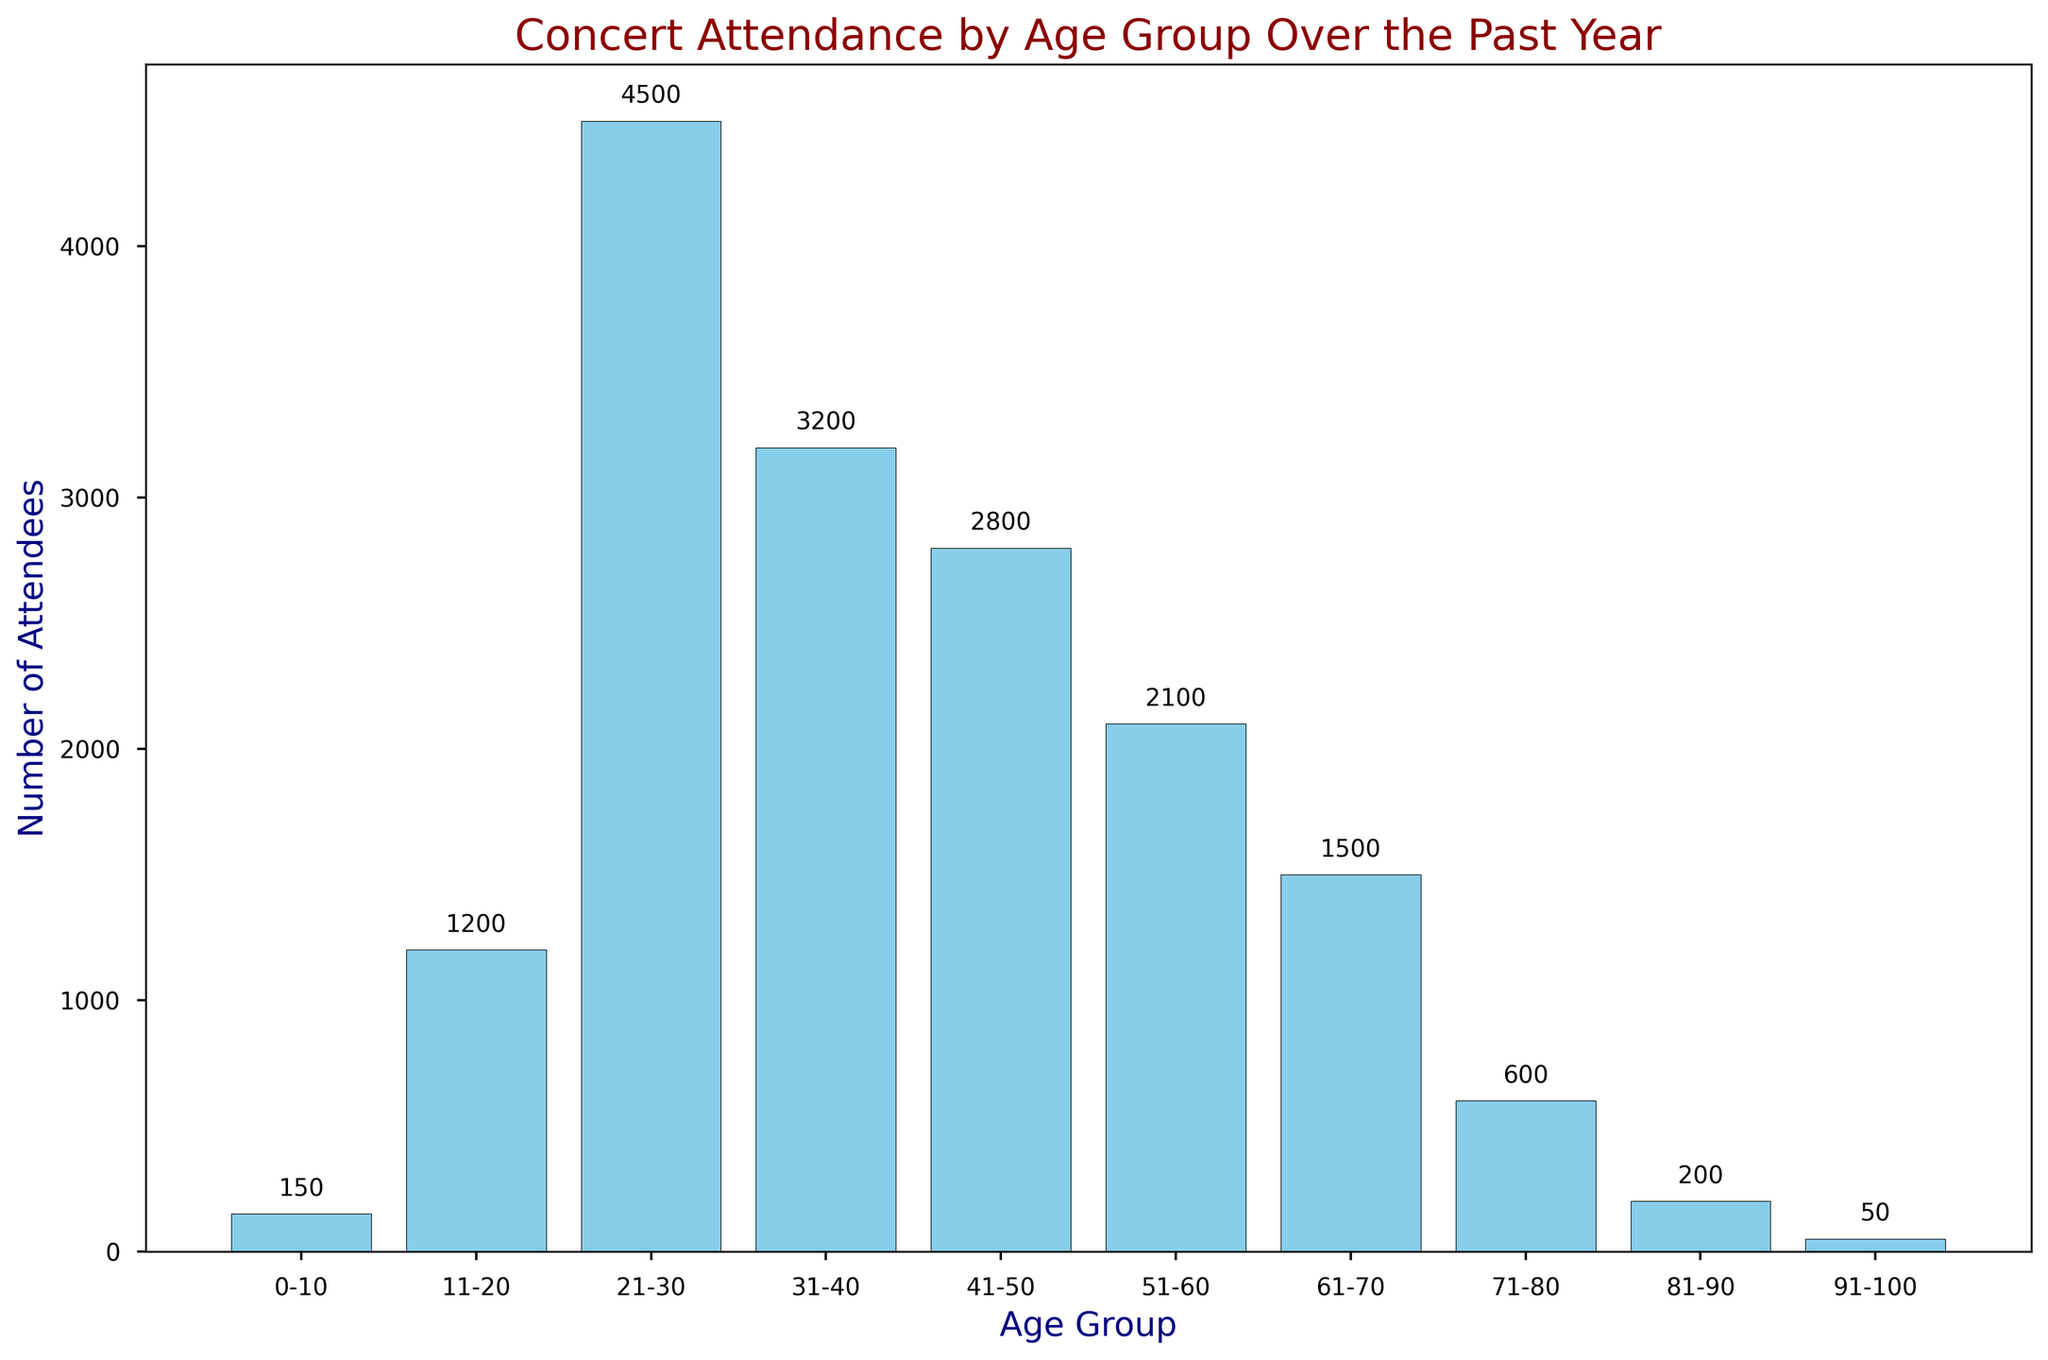What age group has the highest concert attendance? The highest bar represents the age group 21-30, which reaches the tallest point on the y-axis. This indicates that the number of attendees for the age group 21-30 is the largest.
Answer: 21-30 How many more attendees are there in the age group 21-30 compared to the age group 41-50? The number of attendees for the age group 21-30 is 4500, and for 41-50 it is 2800. The difference is calculated by subtracting the number of attendees in the 41-50 group from the 21-30 group: 4500 - 2800 = 1700.
Answer: 1700 What is the total number of attendees for all age groups combined? Summing up the number of attendees for all age groups: 150 + 1200 + 4500 + 3200 + 2800 + 2100 + 1500 + 600 + 200 + 50 = 16300.
Answer: 16300 Which age group has the lowest concert attendance? The smallest bar represents the age group 91-100, which is the shortest and thus the number of attendees is the least.
Answer: 91-100 How does the attendance for the age group 0-10 compare to that of 11-20? The number of attendees for the age group 0-10 is 150, whereas for 11-20 it is 1200. The 11-20 age group has significantly more attendees.
Answer: The age group 11-20 has more attendees Is there any age group where the number of attendees exceeds the combined total of age groups 31-40 and 51-60? The combined number of attendees for age groups 31-40 and 51-60 is 3200 + 2100 = 5300. No single age group exceeds this total since the highest number of attendees in any one age group is 4500 (21-30).
Answer: No What is the average number of attendees across all age groups? To find the average, sum up the total number of attendees and divide by the number of age groups: (150 + 1200 + 4500 + 3200 + 2800 + 2100 + 1500 + 600 + 200 + 50) / 10 = 16300 / 10 = 1630.
Answer: 1630 By how much do the attendees in the age group 61-70 exceed those in the 71-80 group? The number of attendees for age group 61-70 is 1500, and for 71-80 it is 600. The difference is calculated by subtracting the number of attendees in the 71-80 group from the 61-70 group: 1500 - 600 = 900.
Answer: 900 What color are the bars representing the number of attendees? The bars in the histogram are colored skyblue.
Answer: Skyblue 